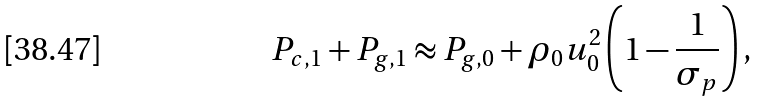Convert formula to latex. <formula><loc_0><loc_0><loc_500><loc_500>P _ { c , 1 } + P _ { g , 1 } \approx P _ { g , 0 } + \rho _ { 0 } u ^ { 2 } _ { 0 } \left ( 1 - \frac { 1 } { \sigma _ { p } } \right ) ,</formula> 